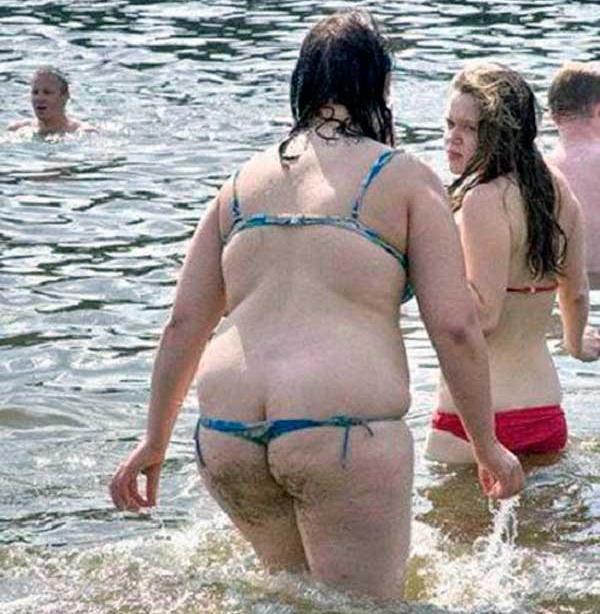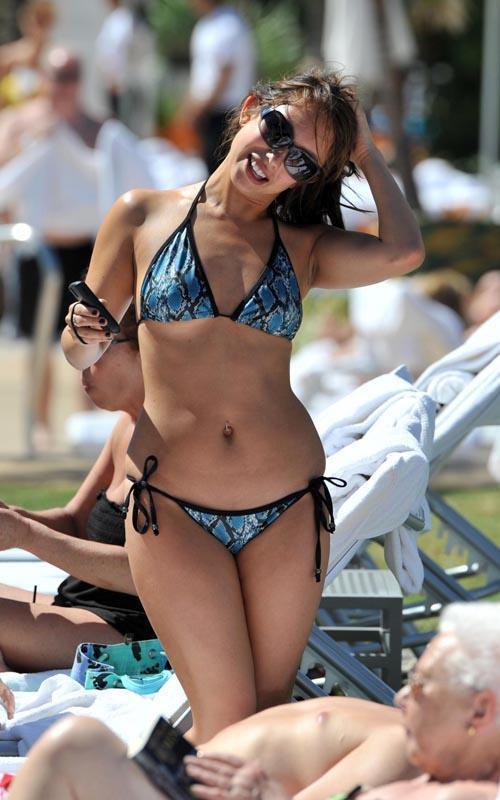The first image is the image on the left, the second image is the image on the right. For the images shown, is this caption "A woman is holding a phone." true? Answer yes or no. Yes. The first image is the image on the left, the second image is the image on the right. Evaluate the accuracy of this statement regarding the images: "There are five women in two pieces suits.". Is it true? Answer yes or no. No. 